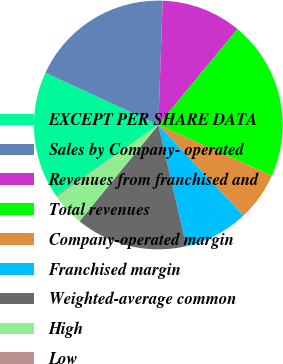Convert chart to OTSL. <chart><loc_0><loc_0><loc_500><loc_500><pie_chart><fcel>EXCEPT PER SHARE DATA<fcel>Sales by Company- operated<fcel>Revenues from franchised and<fcel>Total revenues<fcel>Company-operated margin<fcel>Franchised margin<fcel>Weighted-average common<fcel>High<fcel>Low<nl><fcel>16.59%<fcel>18.65%<fcel>10.43%<fcel>20.71%<fcel>6.31%<fcel>8.37%<fcel>14.54%<fcel>4.26%<fcel>0.14%<nl></chart> 